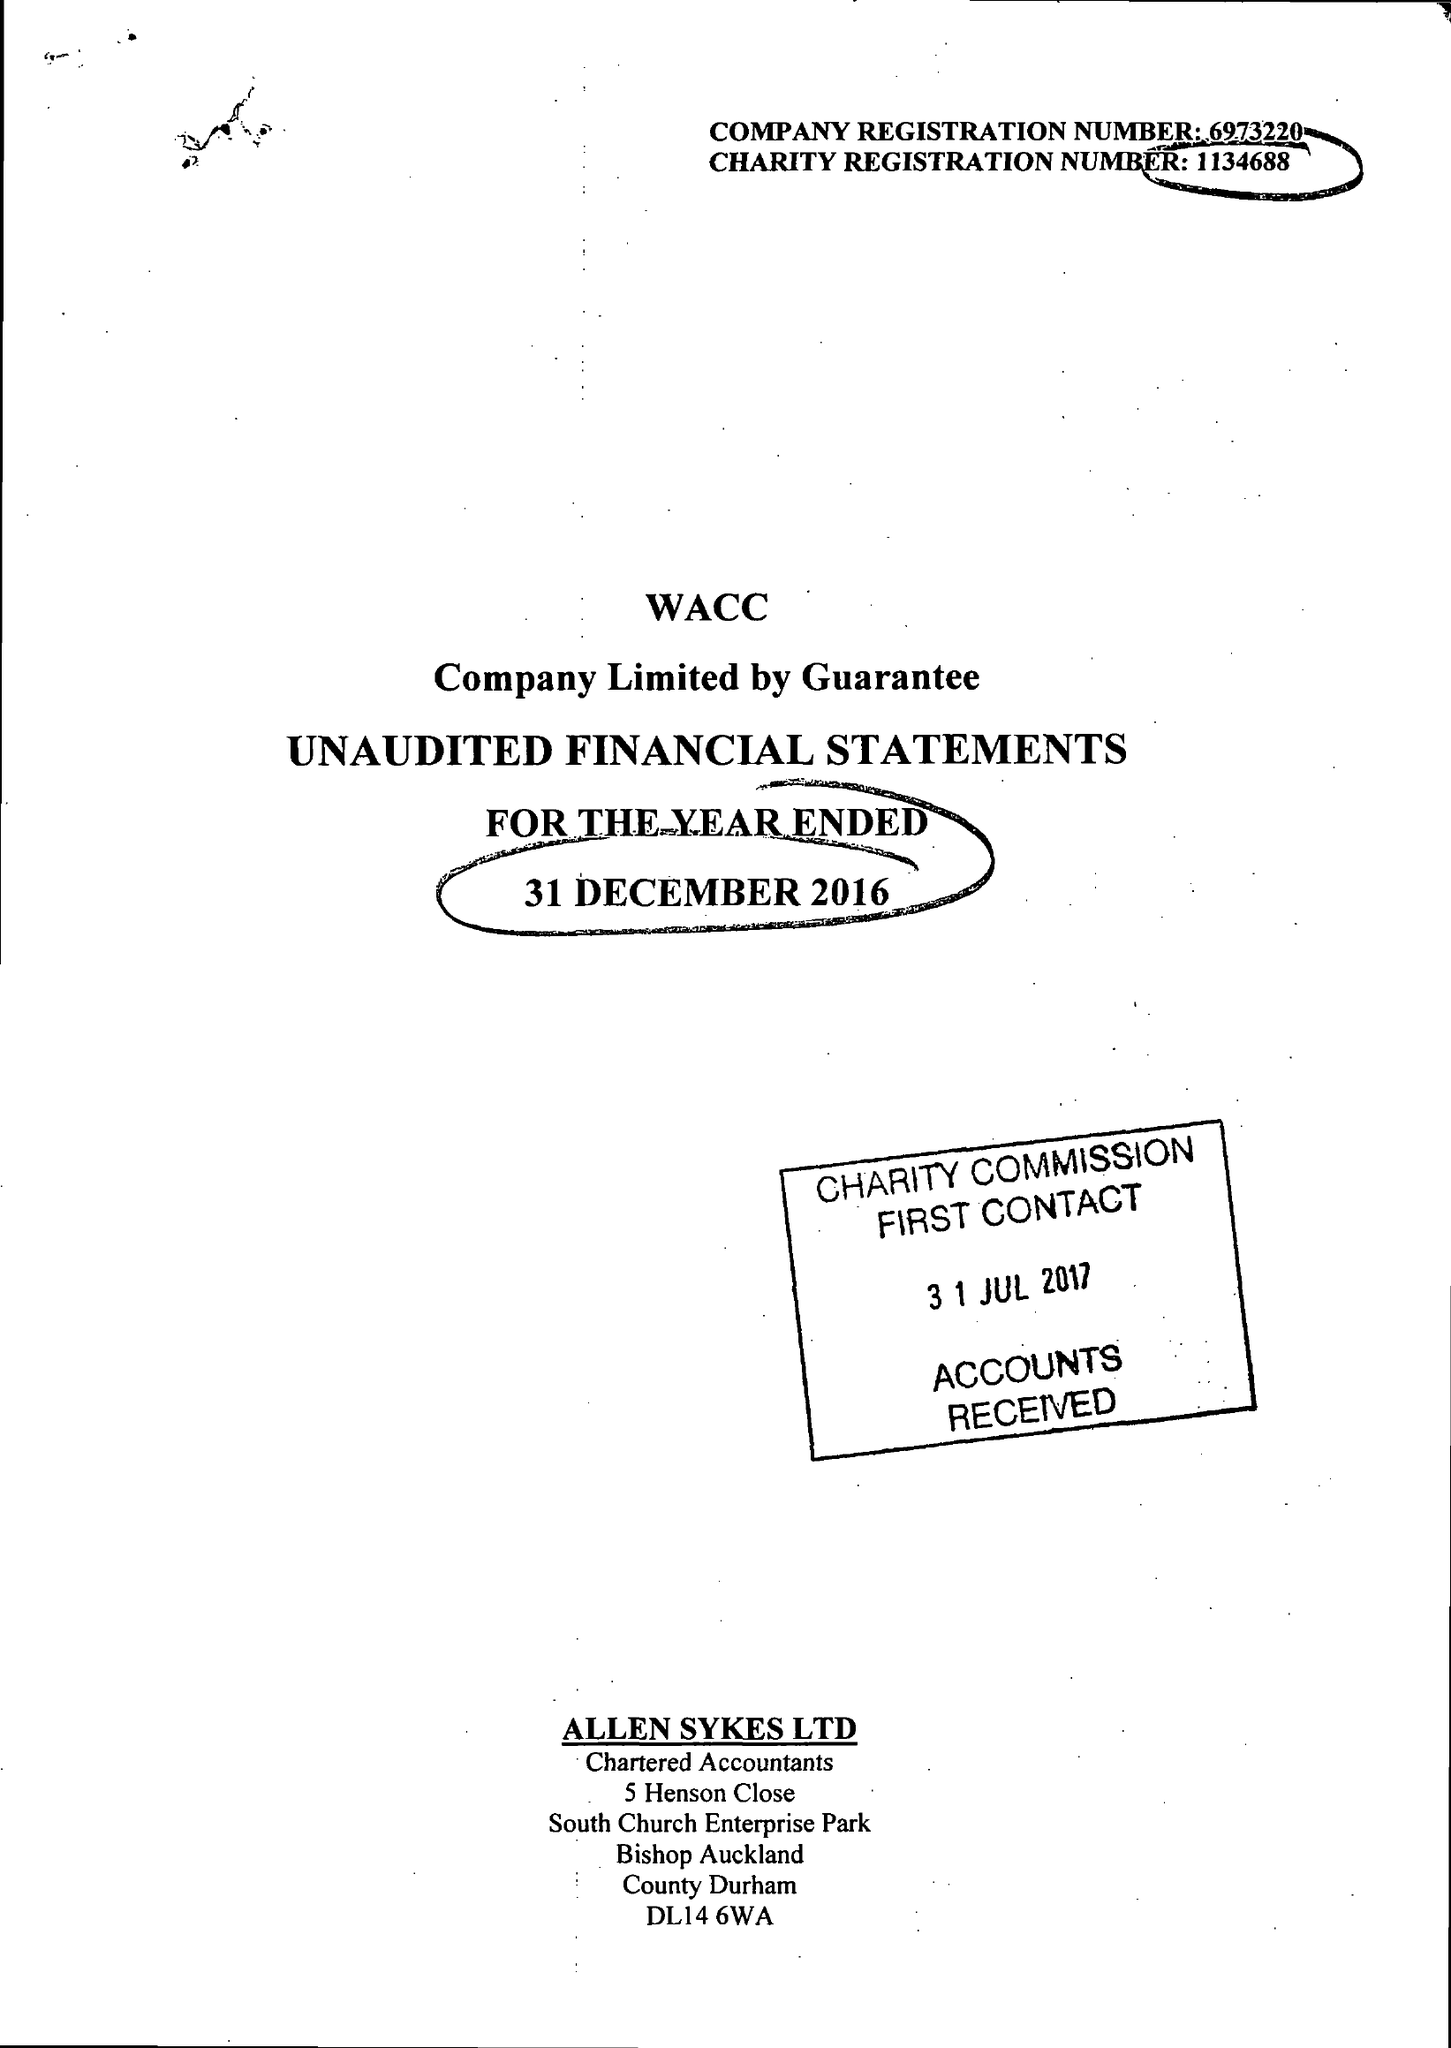What is the value for the charity_name?
Answer the question using a single word or phrase. West Auckland Community Church 